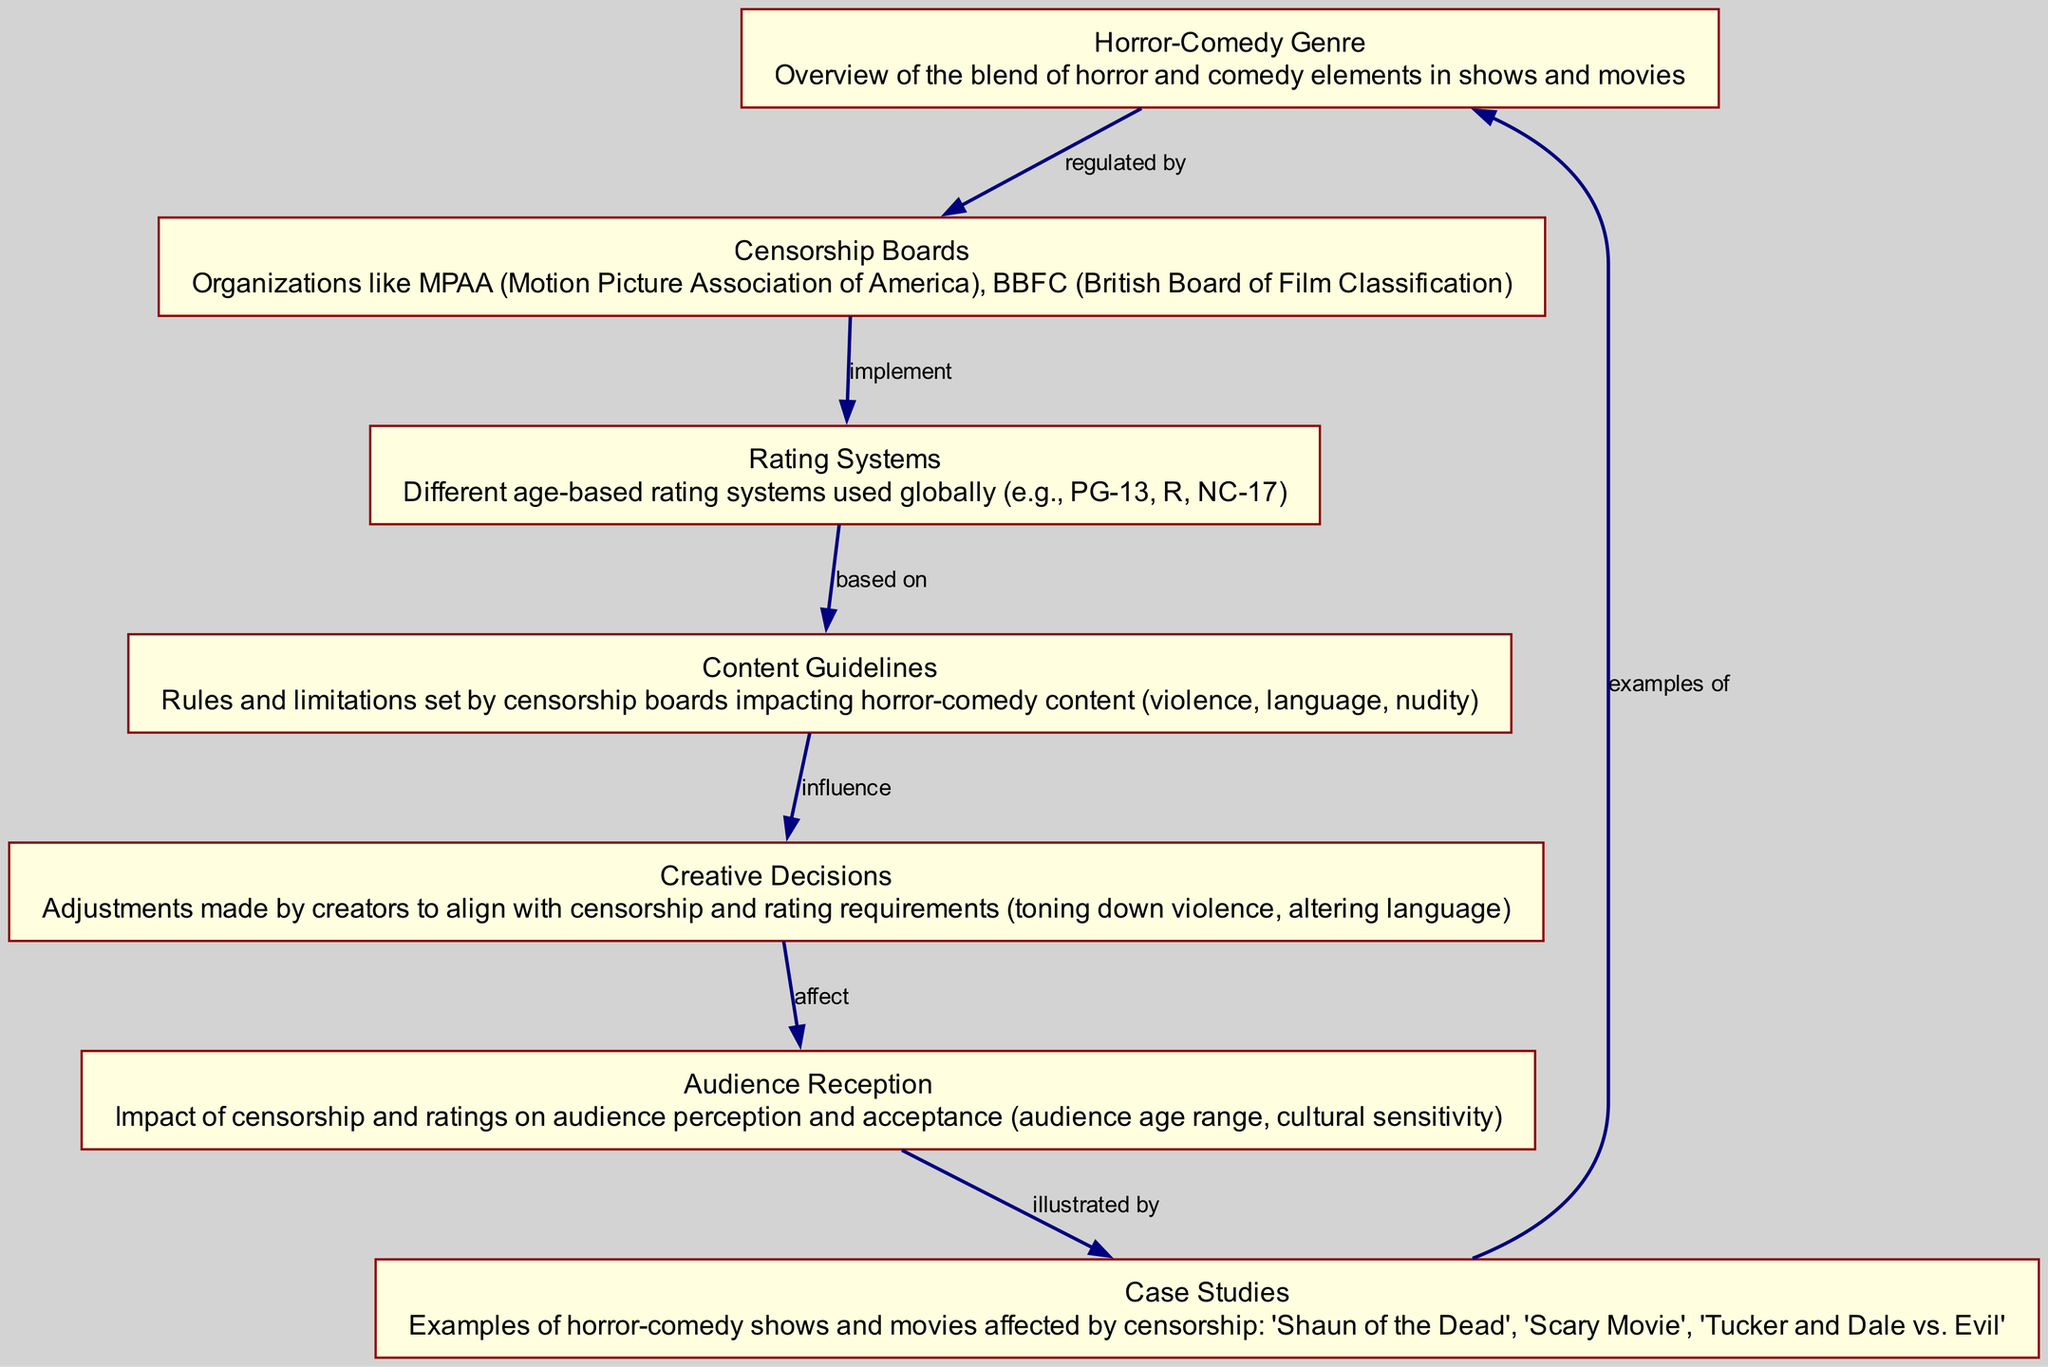what is the total number of blocks in the diagram? The diagram contains seven distinct blocks, as listed under the "blocks" section of the data.
Answer: 7 which organization is mentioned as a censorship board? The data lists the "MPAA" as one example of a censorship board in the diagram.
Answer: MPAA what does the rating system influence? The rating systems influence the "content guidelines" according to the relationship specified in the diagram.
Answer: content guidelines who makes adjustments to align with censorship requirements? The "creative_decisions" block represents the adjustments made by creators to comply with censorship and rating requirements.
Answer: creative decisions how does audience reception relate to case studies? The "audience_reception" block illustrates how audience perception is affected by specific examples provided in the "case_studies" block.
Answer: illustrated by what effect do content guidelines have on creative decisions? The content guidelines "influence" the creative decisions made by creators, emphasizing the direct relationship in the diagram.
Answer: influence which block provides examples of horror-comedy? The "case_studies" block offers specific examples, including shows and movies impacted by censorship, as indicated in the diagram.
Answer: case studies how many relationships are represented in the diagram? The diagram contains six relationships which define how each block is interconnected, specifically detailed in the "relationships" section of the data.
Answer: 6 what is the last block mentioned in the diagram? The last block mentioned in the diagram is "case_studies," which is connected back to the "horror_comedy_genre."
Answer: case studies 